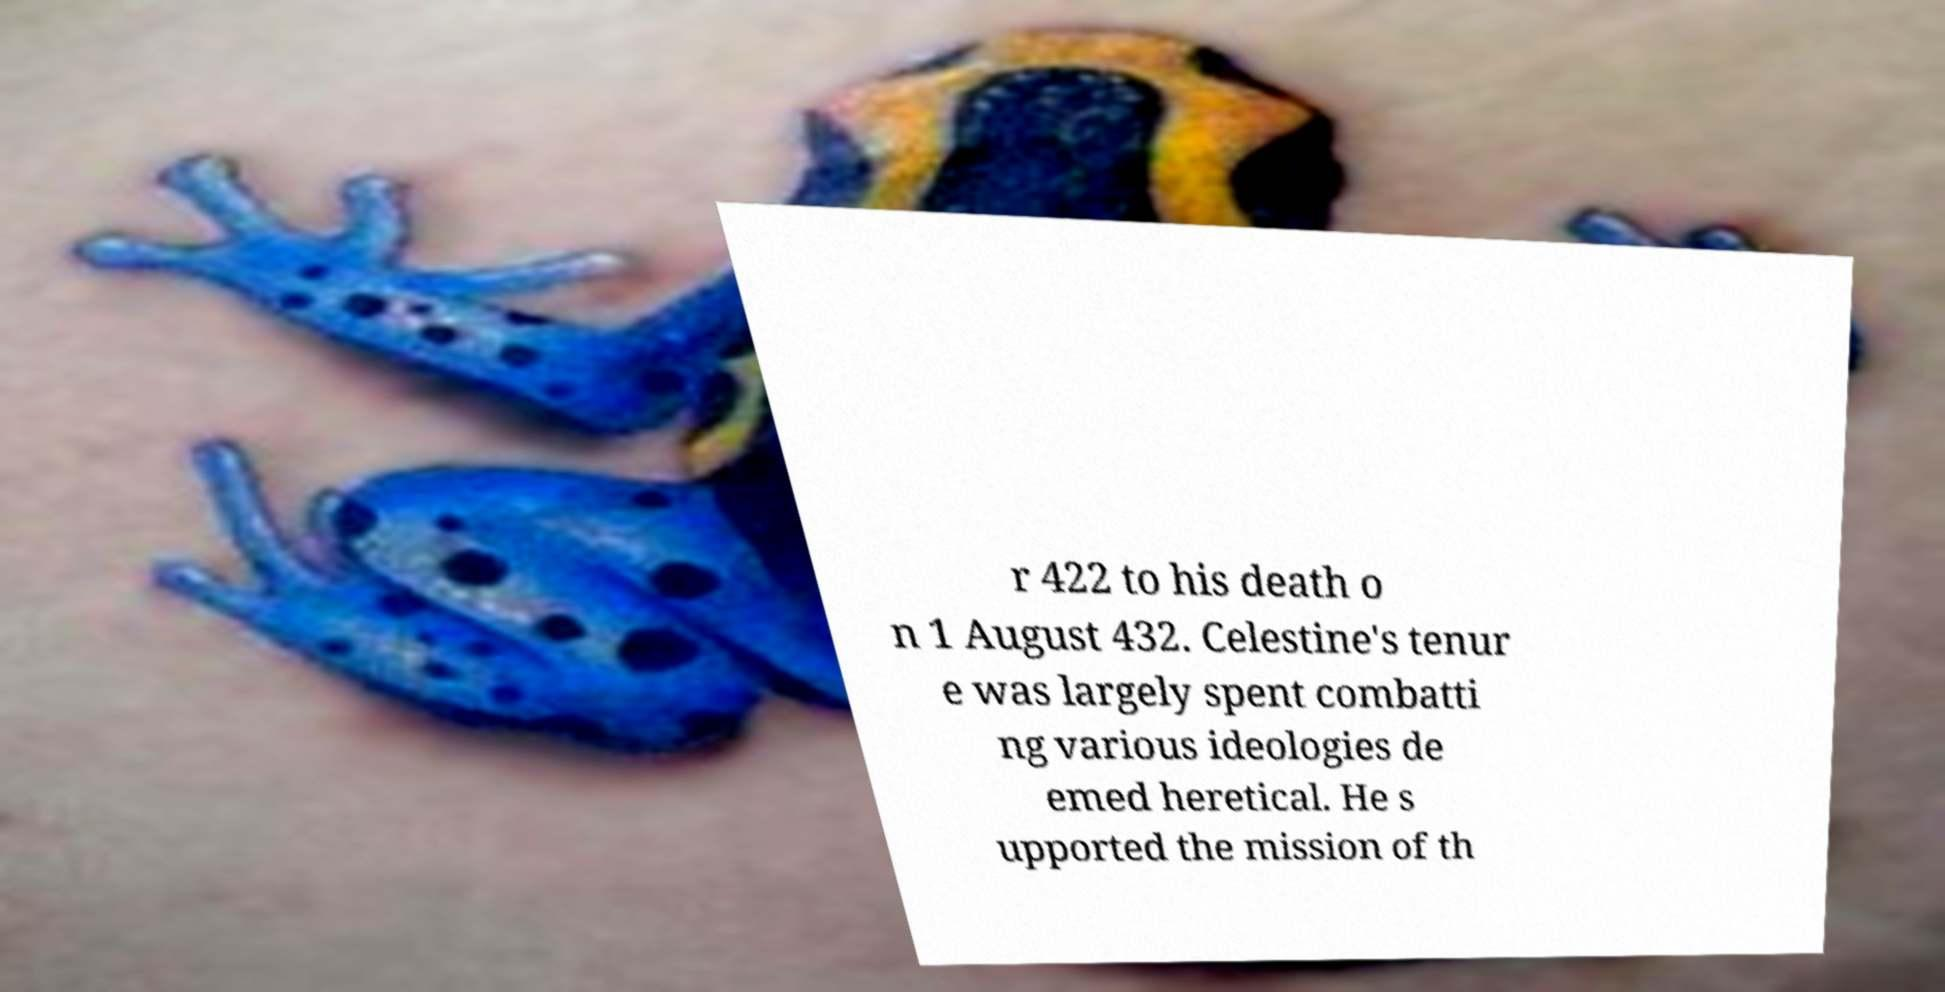Please identify and transcribe the text found in this image. r 422 to his death o n 1 August 432. Celestine's tenur e was largely spent combatti ng various ideologies de emed heretical. He s upported the mission of th 